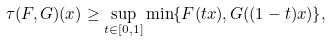Convert formula to latex. <formula><loc_0><loc_0><loc_500><loc_500>\tau ( F , G ) ( x ) \geq \sup _ { t \in [ 0 , 1 ] } \min \{ F ( t x ) , G ( ( 1 - t ) x ) \} , \,</formula> 